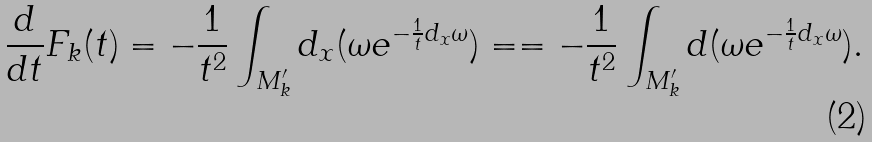<formula> <loc_0><loc_0><loc_500><loc_500>\frac { d } { d t } F _ { k } ( t ) = - \frac { 1 } { t ^ { 2 } } \int _ { M _ { k } ^ { \prime } } d _ { x } ( \omega e ^ { - \frac { 1 } { t } d _ { x } \omega } ) = = - \frac { 1 } { t ^ { 2 } } \int _ { M _ { k } ^ { \prime } } d ( \omega e ^ { - \frac { 1 } { t } d _ { x } \omega } ) .</formula> 